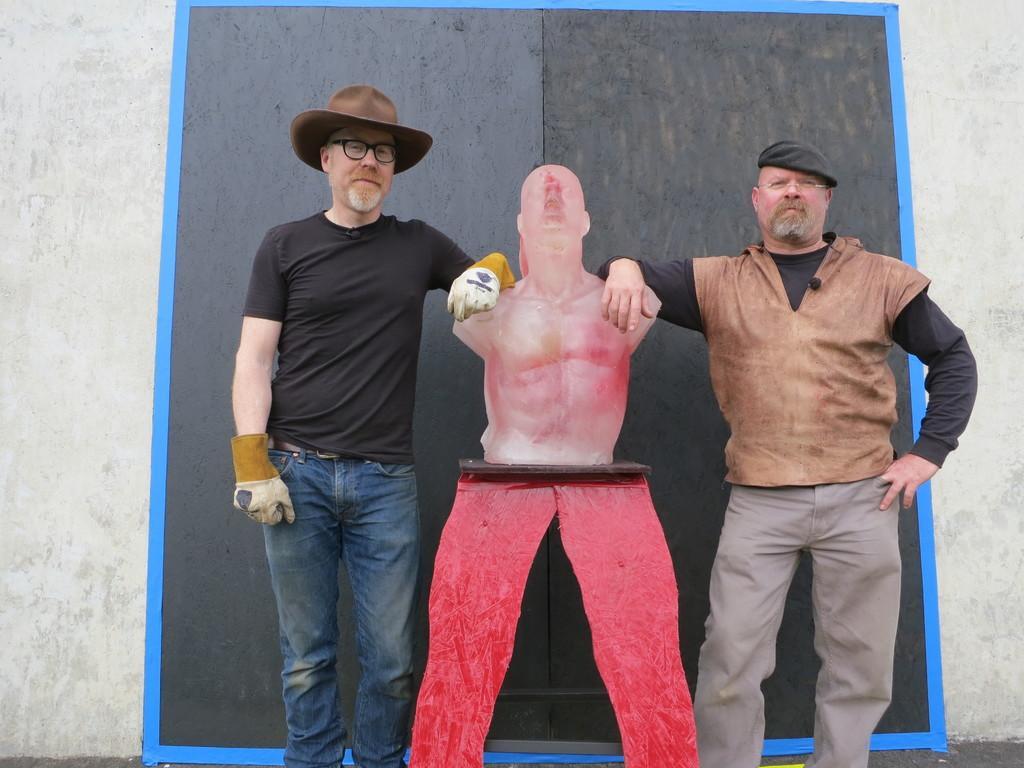Could you give a brief overview of what you see in this image? In this image we can see men standing on the floor by holding a statue. In the background there are walls. 